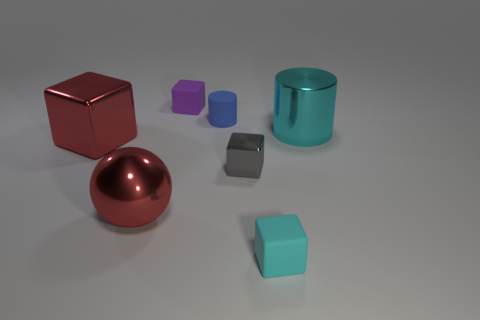Subtract all brown blocks. Subtract all gray spheres. How many blocks are left? 4 Add 3 purple rubber blocks. How many objects exist? 10 Subtract all cylinders. How many objects are left? 5 Subtract all tiny purple metallic cubes. Subtract all cyan metallic cylinders. How many objects are left? 6 Add 7 small gray metallic things. How many small gray metallic things are left? 8 Add 4 small matte cubes. How many small matte cubes exist? 6 Subtract 0 green balls. How many objects are left? 7 